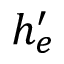Convert formula to latex. <formula><loc_0><loc_0><loc_500><loc_500>h _ { e } ^ { \prime }</formula> 